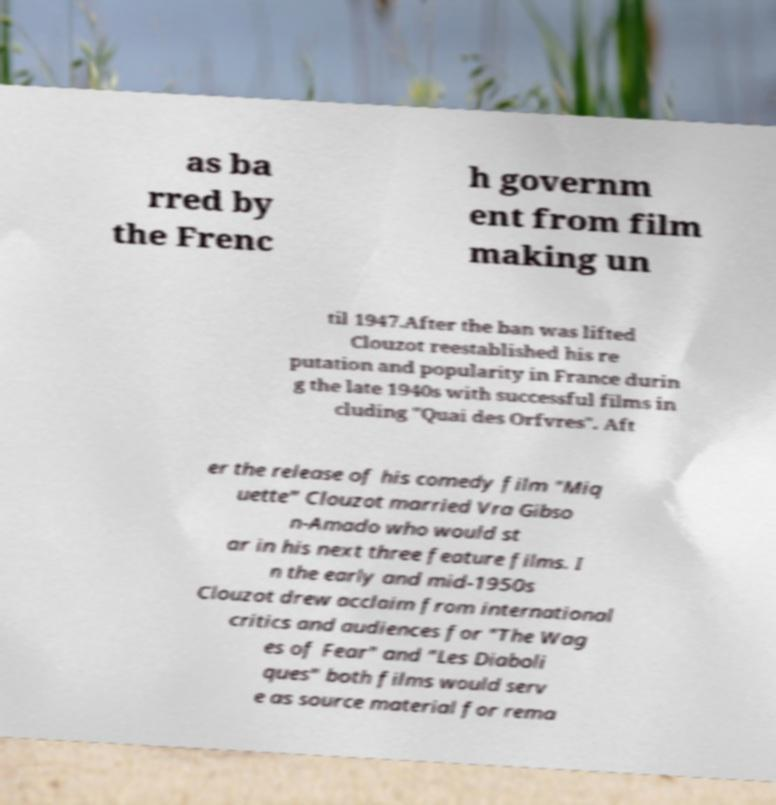Can you accurately transcribe the text from the provided image for me? as ba rred by the Frenc h governm ent from film making un til 1947.After the ban was lifted Clouzot reestablished his re putation and popularity in France durin g the late 1940s with successful films in cluding "Quai des Orfvres". Aft er the release of his comedy film "Miq uette" Clouzot married Vra Gibso n-Amado who would st ar in his next three feature films. I n the early and mid-1950s Clouzot drew acclaim from international critics and audiences for "The Wag es of Fear" and "Les Diaboli ques" both films would serv e as source material for rema 